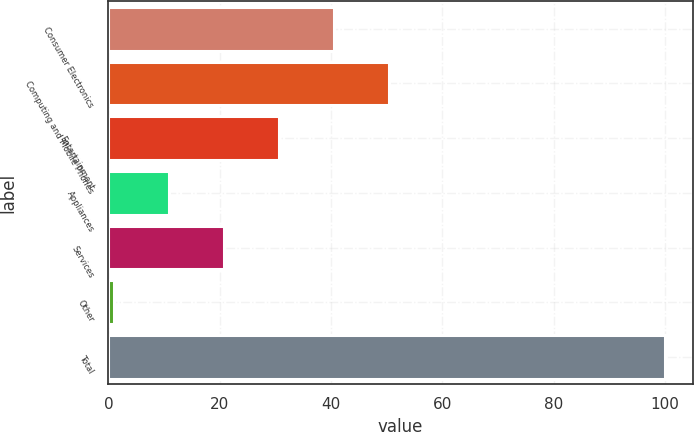Convert chart to OTSL. <chart><loc_0><loc_0><loc_500><loc_500><bar_chart><fcel>Consumer Electronics<fcel>Computing and Mobile Phones<fcel>Entertainment<fcel>Appliances<fcel>Services<fcel>Other<fcel>Total<nl><fcel>40.6<fcel>50.5<fcel>30.7<fcel>10.9<fcel>20.8<fcel>1<fcel>100<nl></chart> 